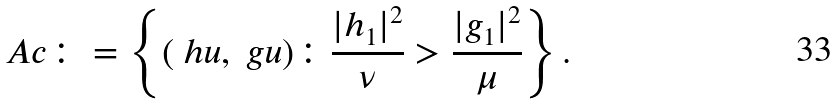Convert formula to latex. <formula><loc_0><loc_0><loc_500><loc_500>\ A c \colon = \left \{ ( \ h u , \ g u ) \colon \frac { | h _ { 1 } | ^ { 2 } } { \nu } > \frac { | g _ { 1 } | ^ { 2 } } { \mu } \right \} .</formula> 